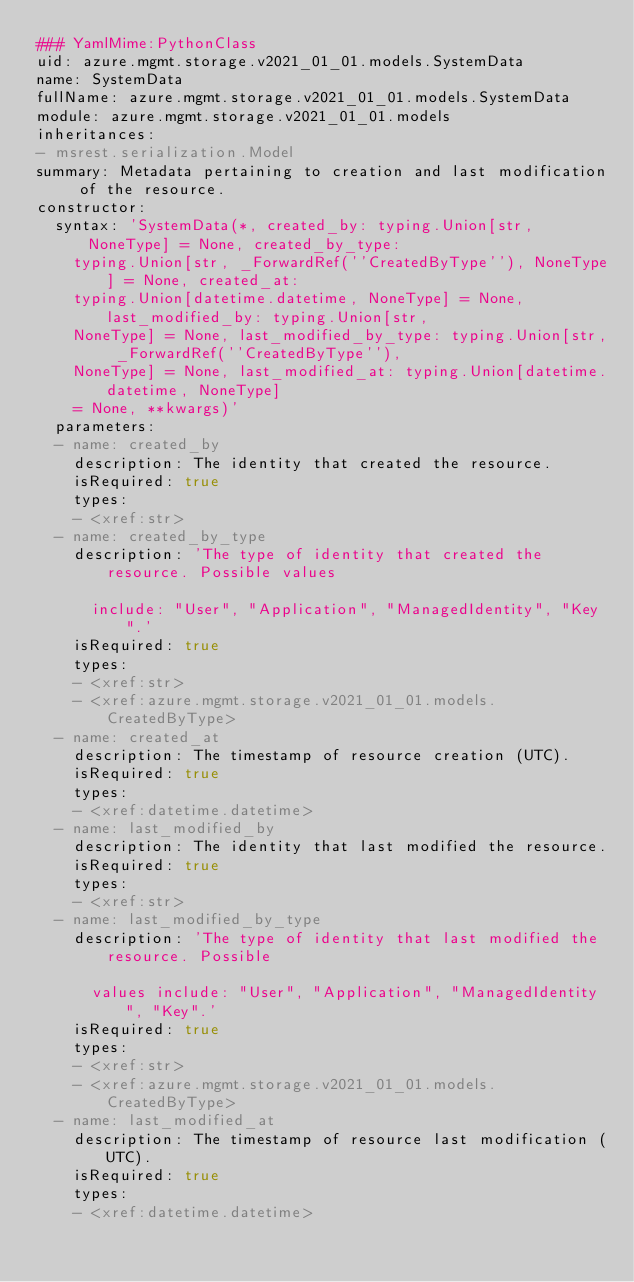Convert code to text. <code><loc_0><loc_0><loc_500><loc_500><_YAML_>### YamlMime:PythonClass
uid: azure.mgmt.storage.v2021_01_01.models.SystemData
name: SystemData
fullName: azure.mgmt.storage.v2021_01_01.models.SystemData
module: azure.mgmt.storage.v2021_01_01.models
inheritances:
- msrest.serialization.Model
summary: Metadata pertaining to creation and last modification of the resource.
constructor:
  syntax: 'SystemData(*, created_by: typing.Union[str, NoneType] = None, created_by_type:
    typing.Union[str, _ForwardRef(''CreatedByType''), NoneType] = None, created_at:
    typing.Union[datetime.datetime, NoneType] = None, last_modified_by: typing.Union[str,
    NoneType] = None, last_modified_by_type: typing.Union[str, _ForwardRef(''CreatedByType''),
    NoneType] = None, last_modified_at: typing.Union[datetime.datetime, NoneType]
    = None, **kwargs)'
  parameters:
  - name: created_by
    description: The identity that created the resource.
    isRequired: true
    types:
    - <xref:str>
  - name: created_by_type
    description: 'The type of identity that created the resource. Possible values

      include: "User", "Application", "ManagedIdentity", "Key".'
    isRequired: true
    types:
    - <xref:str>
    - <xref:azure.mgmt.storage.v2021_01_01.models.CreatedByType>
  - name: created_at
    description: The timestamp of resource creation (UTC).
    isRequired: true
    types:
    - <xref:datetime.datetime>
  - name: last_modified_by
    description: The identity that last modified the resource.
    isRequired: true
    types:
    - <xref:str>
  - name: last_modified_by_type
    description: 'The type of identity that last modified the resource. Possible

      values include: "User", "Application", "ManagedIdentity", "Key".'
    isRequired: true
    types:
    - <xref:str>
    - <xref:azure.mgmt.storage.v2021_01_01.models.CreatedByType>
  - name: last_modified_at
    description: The timestamp of resource last modification (UTC).
    isRequired: true
    types:
    - <xref:datetime.datetime>
</code> 